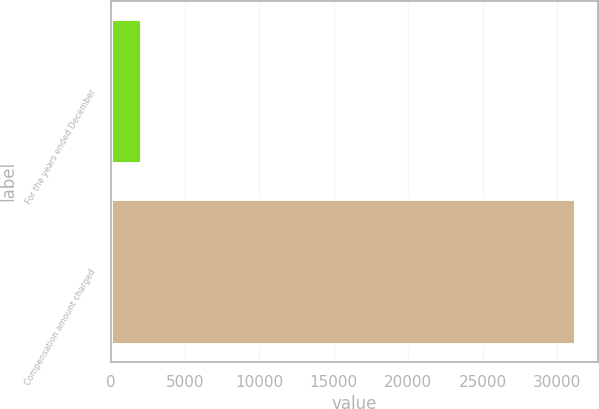<chart> <loc_0><loc_0><loc_500><loc_500><bar_chart><fcel>For the years ended December<fcel>Compensation amount charged<nl><fcel>2012<fcel>31210<nl></chart> 